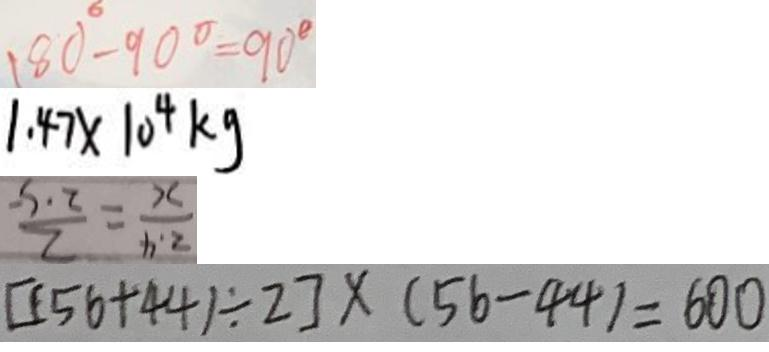Convert formula to latex. <formula><loc_0><loc_0><loc_500><loc_500>1 8 0 ^ { \circ } - 9 0 ^ { \circ } = 9 0 ^ { \circ } 
 1 . 4 7 \times 1 0 ^ { 4 } k g 
 \frac { 2 . 4 } { x } = \frac { 2 } { 2 . 5 } 
 [ ( 5 6 + 4 4 ) \div 2 ] \times ( 5 6 - 4 4 ) = 6 0 0</formula> 